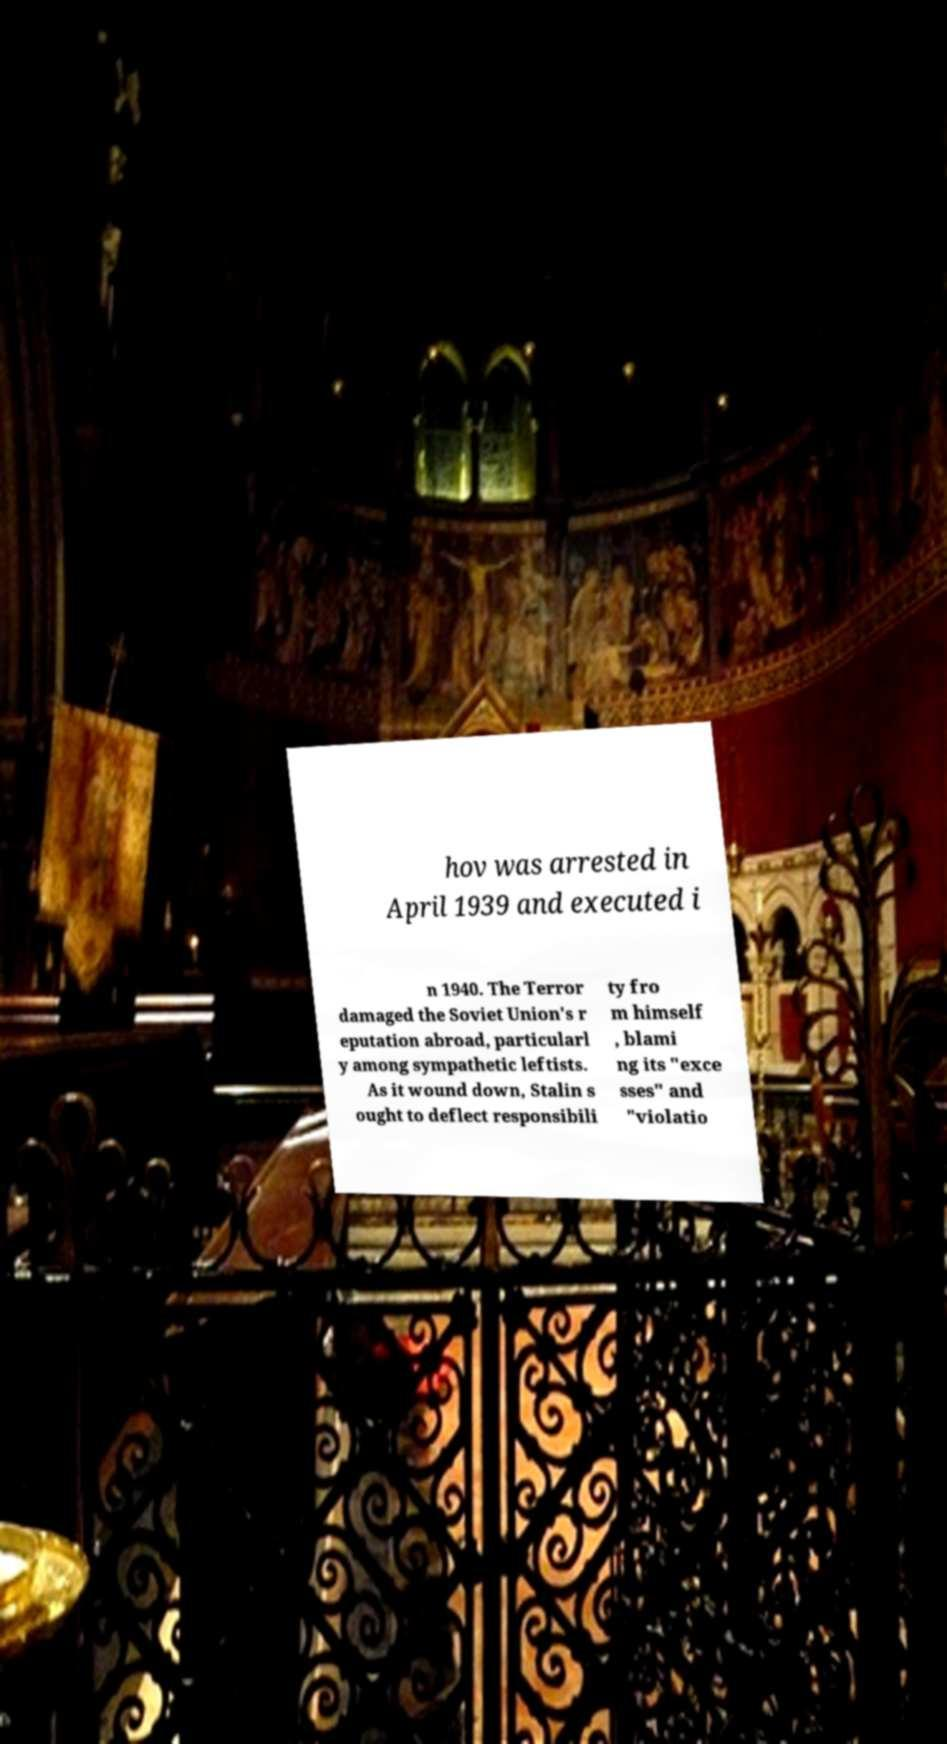Please read and relay the text visible in this image. What does it say? hov was arrested in April 1939 and executed i n 1940. The Terror damaged the Soviet Union's r eputation abroad, particularl y among sympathetic leftists. As it wound down, Stalin s ought to deflect responsibili ty fro m himself , blami ng its "exce sses" and "violatio 